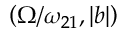Convert formula to latex. <formula><loc_0><loc_0><loc_500><loc_500>\left ( \Omega / \omega _ { 2 1 } , | b | \right )</formula> 